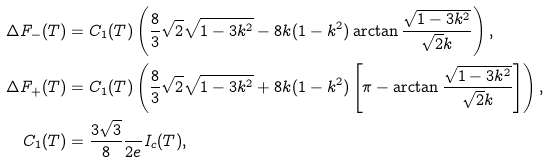Convert formula to latex. <formula><loc_0><loc_0><loc_500><loc_500>\Delta F _ { - } ( T ) & = C _ { 1 } ( T ) \left ( \frac { 8 } { 3 } \sqrt { 2 } \sqrt { 1 - 3 k ^ { 2 } } - 8 k ( 1 - k ^ { 2 } ) \arctan \frac { \sqrt { 1 - 3 k ^ { 2 } } } { \sqrt { 2 } k } \right ) , \\ \Delta F _ { + } ( T ) & = C _ { 1 } ( T ) \left ( \frac { 8 } { 3 } \sqrt { 2 } \sqrt { 1 - 3 k ^ { 2 } } + 8 k ( 1 - k ^ { 2 } ) \left [ \pi - \arctan \frac { \sqrt { 1 - 3 k ^ { 2 } } } { \sqrt { 2 } k } \right ] \right ) , \\ C _ { 1 } ( T ) & = \frac { 3 \sqrt { 3 } } { 8 } \frac { } { 2 e } I _ { c } ( T ) ,</formula> 